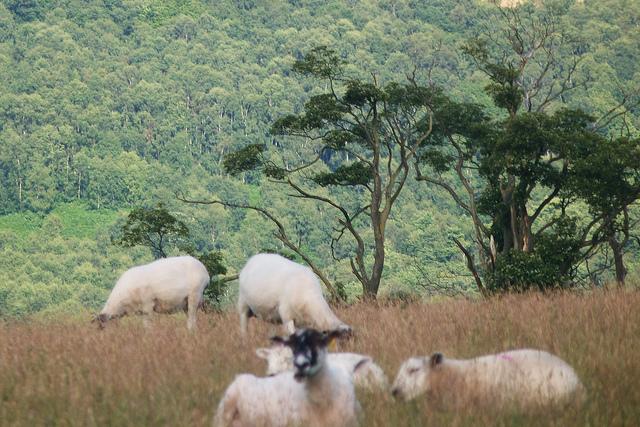What color is the dry grass?
Answer briefly. Brown. How many animals are standing in the dry grass?
Give a very brief answer. 5. What kind of trees are behind the animals?
Keep it brief. Elm. 